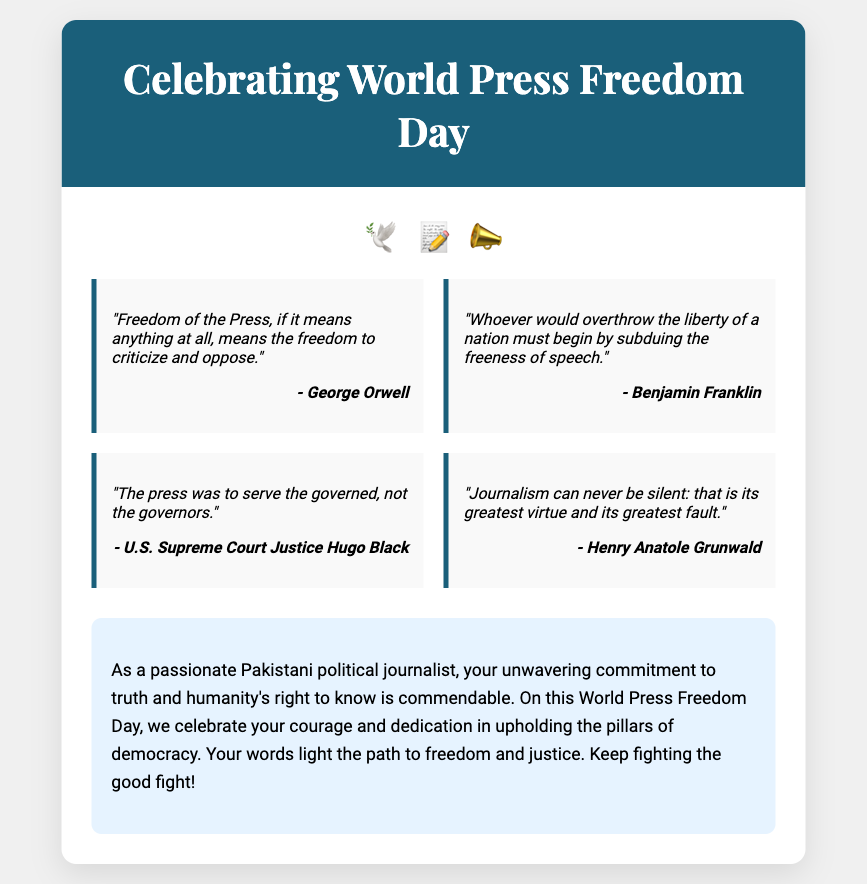what is the main occasion celebrated in the document? The document is a greeting card celebrating World Press Freedom Day.
Answer: World Press Freedom Day who is quoted as saying "Freedom of the Press, if it means anything at all, means the freedom to criticize and oppose"? This quote is attributed to George Orwell in the document.
Answer: George Orwell how many quotes are included in the card? There are four quotes presented in the quotes section of the card.
Answer: Four what decorations are used to enhance the card? The card features symbols of freedom and press, represented by various emojis including a dove, a pen, and a megaphone.
Answer: 🕊️, 📝, 📣 what is the personalized message acknowledging the reader's role in? The message acknowledges the reader's role in upholding press freedom and celebrates their commitment to truth.
Answer: Upholding press freedom which notable figure said "The press was to serve the governed, not the governors"? This quote is attributed to U.S. Supreme Court Justice Hugo Black.
Answer: U.S. Supreme Court Justice Hugo Black what color is the header section of the greeting card? The header section is colored dark blue (#1a5f7a) in the document.
Answer: Dark blue what is the font used for the main title of the card? The main title is styled using the 'Playfair Display' font in the greeting card.
Answer: Playfair Display 